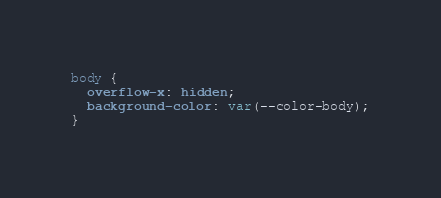Convert code to text. <code><loc_0><loc_0><loc_500><loc_500><_CSS_>body {
  overflow-x: hidden;
  background-color: var(--color-body);
}
</code> 